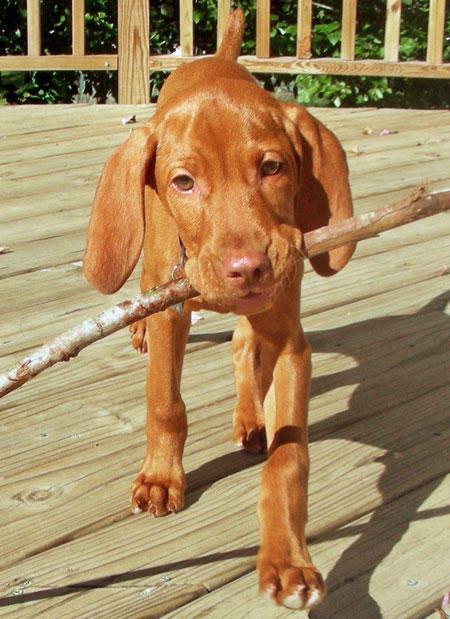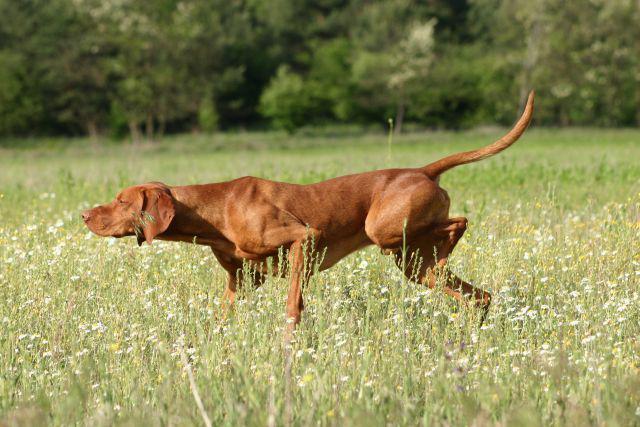The first image is the image on the left, the second image is the image on the right. Assess this claim about the two images: "One of the images shows a dog standing in green grass with a leg up in the air.". Correct or not? Answer yes or no. Yes. The first image is the image on the left, the second image is the image on the right. Examine the images to the left and right. Is the description "One image shows a standing dog holding a long tan item in its mouth." accurate? Answer yes or no. Yes. 